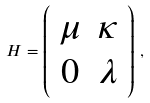Convert formula to latex. <formula><loc_0><loc_0><loc_500><loc_500>H = \left ( \begin{array} { c c } \mu & \kappa \\ 0 & \lambda \end{array} \right ) \, ,</formula> 